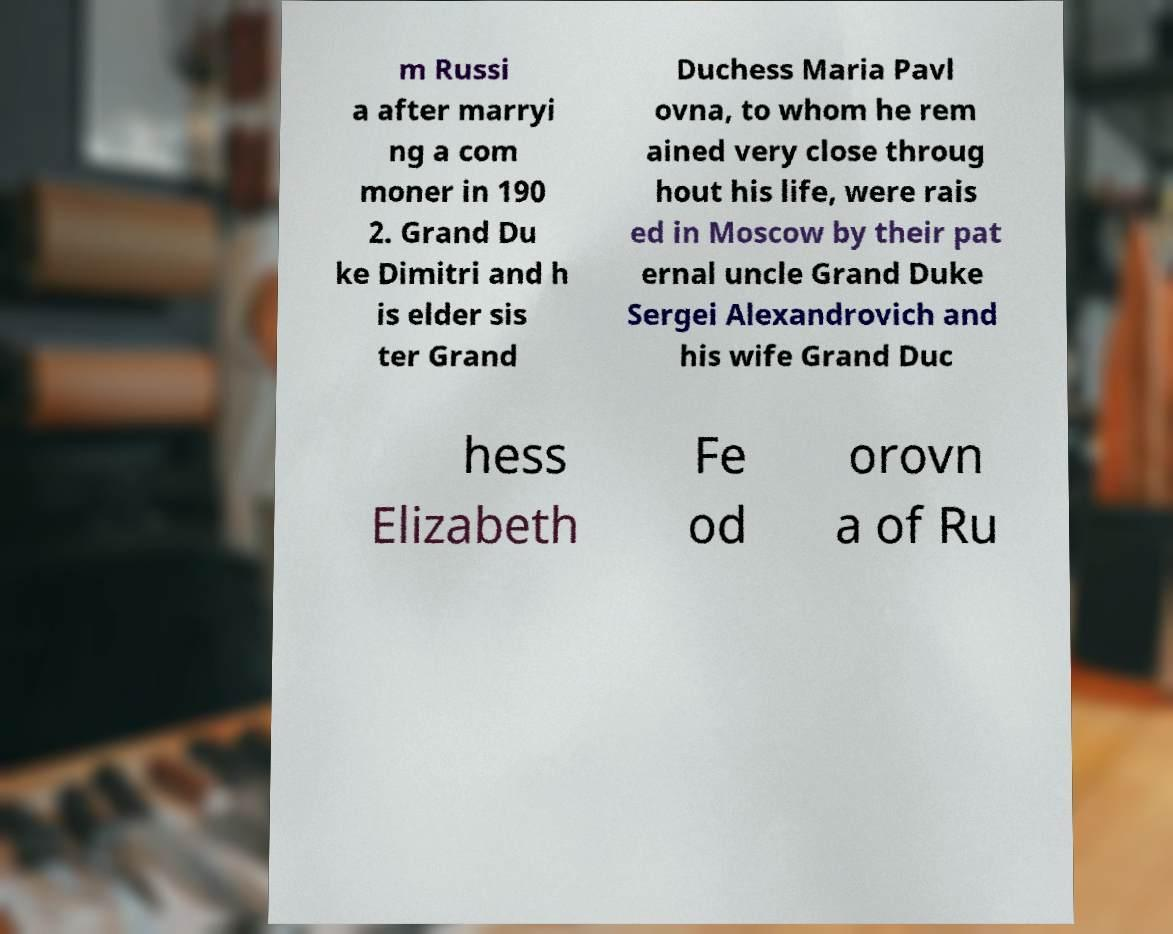For documentation purposes, I need the text within this image transcribed. Could you provide that? m Russi a after marryi ng a com moner in 190 2. Grand Du ke Dimitri and h is elder sis ter Grand Duchess Maria Pavl ovna, to whom he rem ained very close throug hout his life, were rais ed in Moscow by their pat ernal uncle Grand Duke Sergei Alexandrovich and his wife Grand Duc hess Elizabeth Fe od orovn a of Ru 